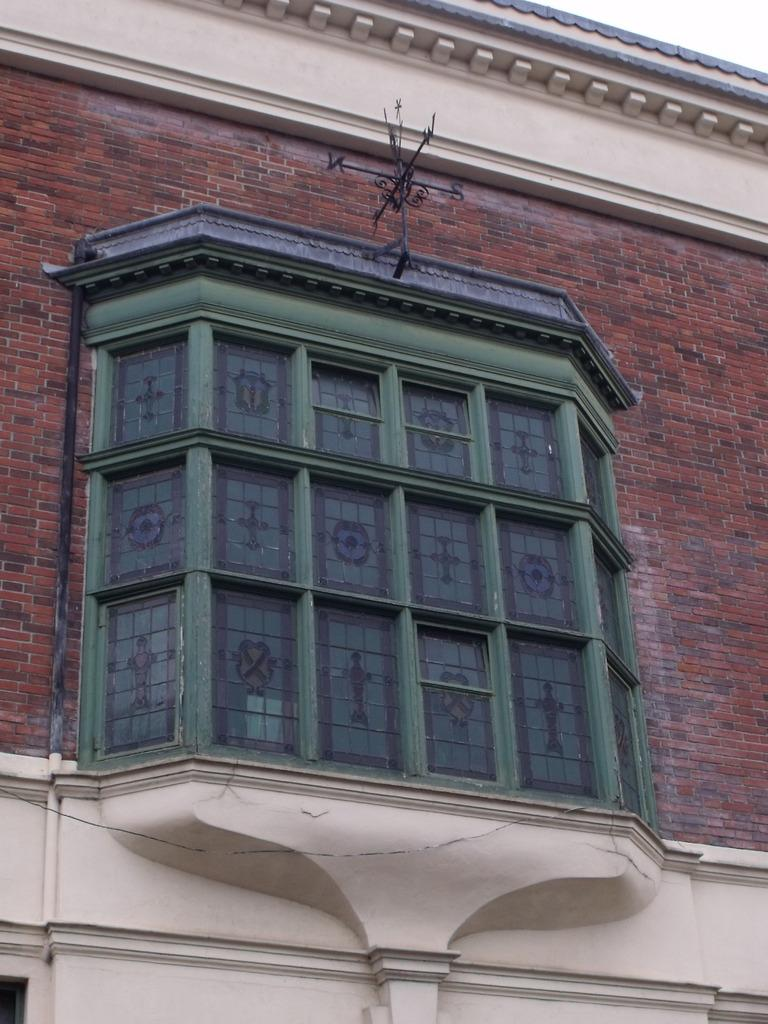What is the main structure visible in the picture? There is a building in the picture. Can you describe any specific features of the building? There is a window in the building. What type of clock is hanging on the wall near the window in the image? There is no clock visible in the image. What kind of bells can be heard ringing in the background of the image? There is no sound or indication of bells in the image. 